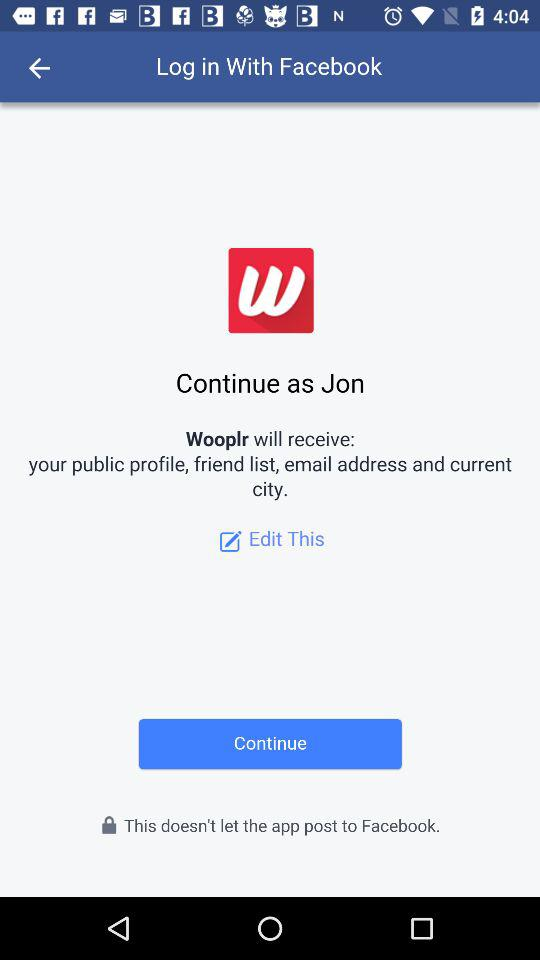What is the user name? The user name is Jon. 